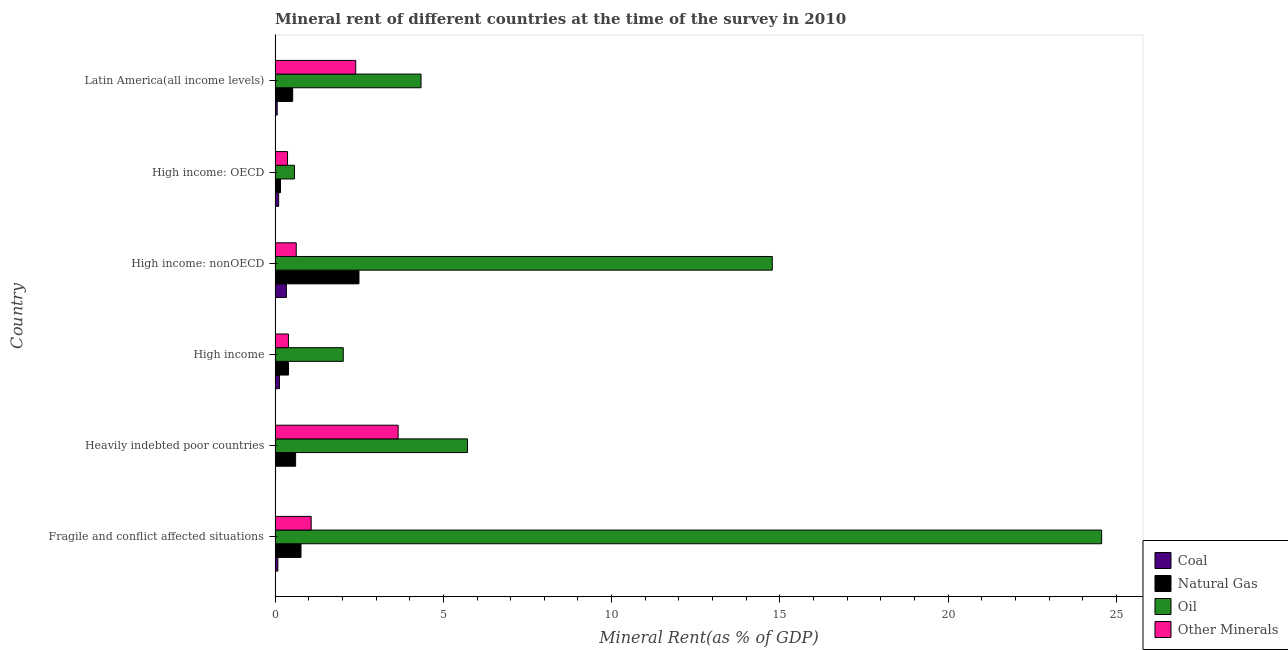How many different coloured bars are there?
Your response must be concise. 4. Are the number of bars on each tick of the Y-axis equal?
Provide a succinct answer. Yes. What is the label of the 4th group of bars from the top?
Offer a terse response. High income. What is the natural gas rent in High income: OECD?
Your answer should be very brief. 0.16. Across all countries, what is the maximum natural gas rent?
Your answer should be compact. 2.49. Across all countries, what is the minimum oil rent?
Give a very brief answer. 0.58. In which country was the  rent of other minerals maximum?
Your response must be concise. Heavily indebted poor countries. In which country was the  rent of other minerals minimum?
Offer a very short reply. High income: OECD. What is the total natural gas rent in the graph?
Give a very brief answer. 4.96. What is the difference between the  rent of other minerals in High income: OECD and that in Latin America(all income levels)?
Offer a terse response. -2.03. What is the difference between the oil rent in High income and the  rent of other minerals in Latin America(all income levels)?
Your answer should be very brief. -0.37. What is the average  rent of other minerals per country?
Offer a terse response. 1.42. What is the difference between the  rent of other minerals and coal rent in Latin America(all income levels)?
Your answer should be compact. 2.33. In how many countries, is the oil rent greater than 4 %?
Your answer should be very brief. 4. What is the ratio of the oil rent in High income to that in Latin America(all income levels)?
Your response must be concise. 0.47. Is the natural gas rent in High income: OECD less than that in High income: nonOECD?
Offer a terse response. Yes. What is the difference between the highest and the second highest coal rent?
Give a very brief answer. 0.21. What is the difference between the highest and the lowest oil rent?
Your answer should be compact. 23.98. Is the sum of the coal rent in Heavily indebted poor countries and High income greater than the maximum natural gas rent across all countries?
Offer a terse response. No. Is it the case that in every country, the sum of the coal rent and  rent of other minerals is greater than the sum of natural gas rent and oil rent?
Offer a terse response. No. What does the 1st bar from the top in High income: OECD represents?
Your answer should be compact. Other Minerals. What does the 4th bar from the bottom in Fragile and conflict affected situations represents?
Ensure brevity in your answer.  Other Minerals. Is it the case that in every country, the sum of the coal rent and natural gas rent is greater than the oil rent?
Offer a terse response. No. How many bars are there?
Your answer should be compact. 24. Are all the bars in the graph horizontal?
Make the answer very short. Yes. How many countries are there in the graph?
Your answer should be very brief. 6. What is the difference between two consecutive major ticks on the X-axis?
Your response must be concise. 5. Does the graph contain any zero values?
Make the answer very short. No. Does the graph contain grids?
Your answer should be very brief. No. Where does the legend appear in the graph?
Your response must be concise. Bottom right. How many legend labels are there?
Offer a terse response. 4. What is the title of the graph?
Your answer should be compact. Mineral rent of different countries at the time of the survey in 2010. What is the label or title of the X-axis?
Your answer should be very brief. Mineral Rent(as % of GDP). What is the Mineral Rent(as % of GDP) of Coal in Fragile and conflict affected situations?
Ensure brevity in your answer.  0.08. What is the Mineral Rent(as % of GDP) of Natural Gas in Fragile and conflict affected situations?
Provide a short and direct response. 0.77. What is the Mineral Rent(as % of GDP) in Oil in Fragile and conflict affected situations?
Offer a terse response. 24.56. What is the Mineral Rent(as % of GDP) in Other Minerals in Fragile and conflict affected situations?
Make the answer very short. 1.07. What is the Mineral Rent(as % of GDP) in Coal in Heavily indebted poor countries?
Your answer should be very brief. 0.01. What is the Mineral Rent(as % of GDP) of Natural Gas in Heavily indebted poor countries?
Offer a terse response. 0.61. What is the Mineral Rent(as % of GDP) in Oil in Heavily indebted poor countries?
Your answer should be compact. 5.72. What is the Mineral Rent(as % of GDP) of Other Minerals in Heavily indebted poor countries?
Provide a succinct answer. 3.66. What is the Mineral Rent(as % of GDP) of Coal in High income?
Provide a succinct answer. 0.13. What is the Mineral Rent(as % of GDP) in Natural Gas in High income?
Offer a very short reply. 0.4. What is the Mineral Rent(as % of GDP) in Oil in High income?
Your answer should be very brief. 2.03. What is the Mineral Rent(as % of GDP) in Other Minerals in High income?
Provide a short and direct response. 0.4. What is the Mineral Rent(as % of GDP) in Coal in High income: nonOECD?
Ensure brevity in your answer.  0.34. What is the Mineral Rent(as % of GDP) in Natural Gas in High income: nonOECD?
Provide a succinct answer. 2.49. What is the Mineral Rent(as % of GDP) of Oil in High income: nonOECD?
Your response must be concise. 14.77. What is the Mineral Rent(as % of GDP) in Other Minerals in High income: nonOECD?
Your answer should be very brief. 0.63. What is the Mineral Rent(as % of GDP) of Coal in High income: OECD?
Give a very brief answer. 0.11. What is the Mineral Rent(as % of GDP) in Natural Gas in High income: OECD?
Offer a very short reply. 0.16. What is the Mineral Rent(as % of GDP) in Oil in High income: OECD?
Your answer should be very brief. 0.58. What is the Mineral Rent(as % of GDP) in Other Minerals in High income: OECD?
Your response must be concise. 0.37. What is the Mineral Rent(as % of GDP) in Coal in Latin America(all income levels)?
Offer a terse response. 0.06. What is the Mineral Rent(as % of GDP) of Natural Gas in Latin America(all income levels)?
Your answer should be very brief. 0.52. What is the Mineral Rent(as % of GDP) in Oil in Latin America(all income levels)?
Give a very brief answer. 4.34. What is the Mineral Rent(as % of GDP) in Other Minerals in Latin America(all income levels)?
Offer a very short reply. 2.4. Across all countries, what is the maximum Mineral Rent(as % of GDP) in Coal?
Offer a terse response. 0.34. Across all countries, what is the maximum Mineral Rent(as % of GDP) of Natural Gas?
Offer a very short reply. 2.49. Across all countries, what is the maximum Mineral Rent(as % of GDP) of Oil?
Give a very brief answer. 24.56. Across all countries, what is the maximum Mineral Rent(as % of GDP) of Other Minerals?
Your response must be concise. 3.66. Across all countries, what is the minimum Mineral Rent(as % of GDP) of Coal?
Offer a terse response. 0.01. Across all countries, what is the minimum Mineral Rent(as % of GDP) of Natural Gas?
Your answer should be very brief. 0.16. Across all countries, what is the minimum Mineral Rent(as % of GDP) in Oil?
Offer a very short reply. 0.58. Across all countries, what is the minimum Mineral Rent(as % of GDP) of Other Minerals?
Provide a succinct answer. 0.37. What is the total Mineral Rent(as % of GDP) of Coal in the graph?
Make the answer very short. 0.73. What is the total Mineral Rent(as % of GDP) in Natural Gas in the graph?
Offer a very short reply. 4.96. What is the total Mineral Rent(as % of GDP) in Oil in the graph?
Give a very brief answer. 51.99. What is the total Mineral Rent(as % of GDP) of Other Minerals in the graph?
Your answer should be very brief. 8.52. What is the difference between the Mineral Rent(as % of GDP) in Coal in Fragile and conflict affected situations and that in Heavily indebted poor countries?
Keep it short and to the point. 0.07. What is the difference between the Mineral Rent(as % of GDP) of Natural Gas in Fragile and conflict affected situations and that in Heavily indebted poor countries?
Offer a very short reply. 0.16. What is the difference between the Mineral Rent(as % of GDP) in Oil in Fragile and conflict affected situations and that in Heavily indebted poor countries?
Make the answer very short. 18.84. What is the difference between the Mineral Rent(as % of GDP) of Other Minerals in Fragile and conflict affected situations and that in Heavily indebted poor countries?
Keep it short and to the point. -2.58. What is the difference between the Mineral Rent(as % of GDP) in Coal in Fragile and conflict affected situations and that in High income?
Give a very brief answer. -0.05. What is the difference between the Mineral Rent(as % of GDP) of Natural Gas in Fragile and conflict affected situations and that in High income?
Provide a succinct answer. 0.37. What is the difference between the Mineral Rent(as % of GDP) of Oil in Fragile and conflict affected situations and that in High income?
Provide a short and direct response. 22.53. What is the difference between the Mineral Rent(as % of GDP) of Other Minerals in Fragile and conflict affected situations and that in High income?
Provide a succinct answer. 0.68. What is the difference between the Mineral Rent(as % of GDP) of Coal in Fragile and conflict affected situations and that in High income: nonOECD?
Give a very brief answer. -0.25. What is the difference between the Mineral Rent(as % of GDP) in Natural Gas in Fragile and conflict affected situations and that in High income: nonOECD?
Ensure brevity in your answer.  -1.72. What is the difference between the Mineral Rent(as % of GDP) of Oil in Fragile and conflict affected situations and that in High income: nonOECD?
Your response must be concise. 9.79. What is the difference between the Mineral Rent(as % of GDP) in Other Minerals in Fragile and conflict affected situations and that in High income: nonOECD?
Your answer should be compact. 0.44. What is the difference between the Mineral Rent(as % of GDP) of Coal in Fragile and conflict affected situations and that in High income: OECD?
Your answer should be very brief. -0.02. What is the difference between the Mineral Rent(as % of GDP) in Natural Gas in Fragile and conflict affected situations and that in High income: OECD?
Offer a very short reply. 0.61. What is the difference between the Mineral Rent(as % of GDP) in Oil in Fragile and conflict affected situations and that in High income: OECD?
Ensure brevity in your answer.  23.98. What is the difference between the Mineral Rent(as % of GDP) of Other Minerals in Fragile and conflict affected situations and that in High income: OECD?
Make the answer very short. 0.7. What is the difference between the Mineral Rent(as % of GDP) in Coal in Fragile and conflict affected situations and that in Latin America(all income levels)?
Offer a terse response. 0.02. What is the difference between the Mineral Rent(as % of GDP) in Natural Gas in Fragile and conflict affected situations and that in Latin America(all income levels)?
Your answer should be very brief. 0.25. What is the difference between the Mineral Rent(as % of GDP) of Oil in Fragile and conflict affected situations and that in Latin America(all income levels)?
Ensure brevity in your answer.  20.22. What is the difference between the Mineral Rent(as % of GDP) in Other Minerals in Fragile and conflict affected situations and that in Latin America(all income levels)?
Your response must be concise. -1.32. What is the difference between the Mineral Rent(as % of GDP) in Coal in Heavily indebted poor countries and that in High income?
Provide a succinct answer. -0.12. What is the difference between the Mineral Rent(as % of GDP) in Natural Gas in Heavily indebted poor countries and that in High income?
Your response must be concise. 0.21. What is the difference between the Mineral Rent(as % of GDP) in Oil in Heavily indebted poor countries and that in High income?
Offer a very short reply. 3.69. What is the difference between the Mineral Rent(as % of GDP) of Other Minerals in Heavily indebted poor countries and that in High income?
Offer a terse response. 3.26. What is the difference between the Mineral Rent(as % of GDP) of Coal in Heavily indebted poor countries and that in High income: nonOECD?
Offer a terse response. -0.32. What is the difference between the Mineral Rent(as % of GDP) in Natural Gas in Heavily indebted poor countries and that in High income: nonOECD?
Provide a short and direct response. -1.88. What is the difference between the Mineral Rent(as % of GDP) of Oil in Heavily indebted poor countries and that in High income: nonOECD?
Your answer should be compact. -9.06. What is the difference between the Mineral Rent(as % of GDP) of Other Minerals in Heavily indebted poor countries and that in High income: nonOECD?
Offer a terse response. 3.03. What is the difference between the Mineral Rent(as % of GDP) of Coal in Heavily indebted poor countries and that in High income: OECD?
Offer a terse response. -0.09. What is the difference between the Mineral Rent(as % of GDP) of Natural Gas in Heavily indebted poor countries and that in High income: OECD?
Make the answer very short. 0.45. What is the difference between the Mineral Rent(as % of GDP) of Oil in Heavily indebted poor countries and that in High income: OECD?
Your answer should be compact. 5.14. What is the difference between the Mineral Rent(as % of GDP) in Other Minerals in Heavily indebted poor countries and that in High income: OECD?
Offer a terse response. 3.29. What is the difference between the Mineral Rent(as % of GDP) in Coal in Heavily indebted poor countries and that in Latin America(all income levels)?
Keep it short and to the point. -0.05. What is the difference between the Mineral Rent(as % of GDP) in Natural Gas in Heavily indebted poor countries and that in Latin America(all income levels)?
Keep it short and to the point. 0.09. What is the difference between the Mineral Rent(as % of GDP) in Oil in Heavily indebted poor countries and that in Latin America(all income levels)?
Provide a succinct answer. 1.38. What is the difference between the Mineral Rent(as % of GDP) of Other Minerals in Heavily indebted poor countries and that in Latin America(all income levels)?
Offer a very short reply. 1.26. What is the difference between the Mineral Rent(as % of GDP) of Coal in High income and that in High income: nonOECD?
Provide a succinct answer. -0.21. What is the difference between the Mineral Rent(as % of GDP) of Natural Gas in High income and that in High income: nonOECD?
Offer a very short reply. -2.09. What is the difference between the Mineral Rent(as % of GDP) of Oil in High income and that in High income: nonOECD?
Ensure brevity in your answer.  -12.75. What is the difference between the Mineral Rent(as % of GDP) in Other Minerals in High income and that in High income: nonOECD?
Keep it short and to the point. -0.23. What is the difference between the Mineral Rent(as % of GDP) in Coal in High income and that in High income: OECD?
Provide a short and direct response. 0.02. What is the difference between the Mineral Rent(as % of GDP) in Natural Gas in High income and that in High income: OECD?
Offer a very short reply. 0.24. What is the difference between the Mineral Rent(as % of GDP) in Oil in High income and that in High income: OECD?
Provide a short and direct response. 1.45. What is the difference between the Mineral Rent(as % of GDP) of Other Minerals in High income and that in High income: OECD?
Ensure brevity in your answer.  0.03. What is the difference between the Mineral Rent(as % of GDP) of Coal in High income and that in Latin America(all income levels)?
Make the answer very short. 0.07. What is the difference between the Mineral Rent(as % of GDP) in Natural Gas in High income and that in Latin America(all income levels)?
Your answer should be compact. -0.12. What is the difference between the Mineral Rent(as % of GDP) in Oil in High income and that in Latin America(all income levels)?
Offer a terse response. -2.31. What is the difference between the Mineral Rent(as % of GDP) in Other Minerals in High income and that in Latin America(all income levels)?
Provide a succinct answer. -2. What is the difference between the Mineral Rent(as % of GDP) in Coal in High income: nonOECD and that in High income: OECD?
Your answer should be compact. 0.23. What is the difference between the Mineral Rent(as % of GDP) of Natural Gas in High income: nonOECD and that in High income: OECD?
Your answer should be compact. 2.33. What is the difference between the Mineral Rent(as % of GDP) in Oil in High income: nonOECD and that in High income: OECD?
Offer a very short reply. 14.2. What is the difference between the Mineral Rent(as % of GDP) in Other Minerals in High income: nonOECD and that in High income: OECD?
Offer a terse response. 0.26. What is the difference between the Mineral Rent(as % of GDP) of Coal in High income: nonOECD and that in Latin America(all income levels)?
Offer a very short reply. 0.27. What is the difference between the Mineral Rent(as % of GDP) in Natural Gas in High income: nonOECD and that in Latin America(all income levels)?
Offer a very short reply. 1.97. What is the difference between the Mineral Rent(as % of GDP) in Oil in High income: nonOECD and that in Latin America(all income levels)?
Provide a succinct answer. 10.44. What is the difference between the Mineral Rent(as % of GDP) of Other Minerals in High income: nonOECD and that in Latin America(all income levels)?
Make the answer very short. -1.77. What is the difference between the Mineral Rent(as % of GDP) of Coal in High income: OECD and that in Latin America(all income levels)?
Provide a short and direct response. 0.04. What is the difference between the Mineral Rent(as % of GDP) in Natural Gas in High income: OECD and that in Latin America(all income levels)?
Provide a succinct answer. -0.36. What is the difference between the Mineral Rent(as % of GDP) in Oil in High income: OECD and that in Latin America(all income levels)?
Keep it short and to the point. -3.76. What is the difference between the Mineral Rent(as % of GDP) of Other Minerals in High income: OECD and that in Latin America(all income levels)?
Your answer should be very brief. -2.03. What is the difference between the Mineral Rent(as % of GDP) in Coal in Fragile and conflict affected situations and the Mineral Rent(as % of GDP) in Natural Gas in Heavily indebted poor countries?
Your answer should be very brief. -0.53. What is the difference between the Mineral Rent(as % of GDP) of Coal in Fragile and conflict affected situations and the Mineral Rent(as % of GDP) of Oil in Heavily indebted poor countries?
Ensure brevity in your answer.  -5.63. What is the difference between the Mineral Rent(as % of GDP) in Coal in Fragile and conflict affected situations and the Mineral Rent(as % of GDP) in Other Minerals in Heavily indebted poor countries?
Your answer should be very brief. -3.57. What is the difference between the Mineral Rent(as % of GDP) of Natural Gas in Fragile and conflict affected situations and the Mineral Rent(as % of GDP) of Oil in Heavily indebted poor countries?
Provide a short and direct response. -4.95. What is the difference between the Mineral Rent(as % of GDP) in Natural Gas in Fragile and conflict affected situations and the Mineral Rent(as % of GDP) in Other Minerals in Heavily indebted poor countries?
Your answer should be compact. -2.89. What is the difference between the Mineral Rent(as % of GDP) of Oil in Fragile and conflict affected situations and the Mineral Rent(as % of GDP) of Other Minerals in Heavily indebted poor countries?
Your answer should be compact. 20.9. What is the difference between the Mineral Rent(as % of GDP) in Coal in Fragile and conflict affected situations and the Mineral Rent(as % of GDP) in Natural Gas in High income?
Your response must be concise. -0.32. What is the difference between the Mineral Rent(as % of GDP) in Coal in Fragile and conflict affected situations and the Mineral Rent(as % of GDP) in Oil in High income?
Your answer should be compact. -1.94. What is the difference between the Mineral Rent(as % of GDP) in Coal in Fragile and conflict affected situations and the Mineral Rent(as % of GDP) in Other Minerals in High income?
Offer a terse response. -0.31. What is the difference between the Mineral Rent(as % of GDP) of Natural Gas in Fragile and conflict affected situations and the Mineral Rent(as % of GDP) of Oil in High income?
Provide a short and direct response. -1.26. What is the difference between the Mineral Rent(as % of GDP) of Natural Gas in Fragile and conflict affected situations and the Mineral Rent(as % of GDP) of Other Minerals in High income?
Give a very brief answer. 0.37. What is the difference between the Mineral Rent(as % of GDP) in Oil in Fragile and conflict affected situations and the Mineral Rent(as % of GDP) in Other Minerals in High income?
Your answer should be compact. 24.16. What is the difference between the Mineral Rent(as % of GDP) in Coal in Fragile and conflict affected situations and the Mineral Rent(as % of GDP) in Natural Gas in High income: nonOECD?
Provide a short and direct response. -2.41. What is the difference between the Mineral Rent(as % of GDP) of Coal in Fragile and conflict affected situations and the Mineral Rent(as % of GDP) of Oil in High income: nonOECD?
Your answer should be compact. -14.69. What is the difference between the Mineral Rent(as % of GDP) in Coal in Fragile and conflict affected situations and the Mineral Rent(as % of GDP) in Other Minerals in High income: nonOECD?
Offer a very short reply. -0.55. What is the difference between the Mineral Rent(as % of GDP) in Natural Gas in Fragile and conflict affected situations and the Mineral Rent(as % of GDP) in Oil in High income: nonOECD?
Offer a terse response. -14. What is the difference between the Mineral Rent(as % of GDP) in Natural Gas in Fragile and conflict affected situations and the Mineral Rent(as % of GDP) in Other Minerals in High income: nonOECD?
Your answer should be compact. 0.14. What is the difference between the Mineral Rent(as % of GDP) in Oil in Fragile and conflict affected situations and the Mineral Rent(as % of GDP) in Other Minerals in High income: nonOECD?
Offer a terse response. 23.93. What is the difference between the Mineral Rent(as % of GDP) of Coal in Fragile and conflict affected situations and the Mineral Rent(as % of GDP) of Natural Gas in High income: OECD?
Give a very brief answer. -0.08. What is the difference between the Mineral Rent(as % of GDP) in Coal in Fragile and conflict affected situations and the Mineral Rent(as % of GDP) in Oil in High income: OECD?
Keep it short and to the point. -0.49. What is the difference between the Mineral Rent(as % of GDP) in Coal in Fragile and conflict affected situations and the Mineral Rent(as % of GDP) in Other Minerals in High income: OECD?
Provide a succinct answer. -0.29. What is the difference between the Mineral Rent(as % of GDP) in Natural Gas in Fragile and conflict affected situations and the Mineral Rent(as % of GDP) in Oil in High income: OECD?
Your answer should be compact. 0.19. What is the difference between the Mineral Rent(as % of GDP) of Natural Gas in Fragile and conflict affected situations and the Mineral Rent(as % of GDP) of Other Minerals in High income: OECD?
Offer a very short reply. 0.4. What is the difference between the Mineral Rent(as % of GDP) of Oil in Fragile and conflict affected situations and the Mineral Rent(as % of GDP) of Other Minerals in High income: OECD?
Make the answer very short. 24.19. What is the difference between the Mineral Rent(as % of GDP) of Coal in Fragile and conflict affected situations and the Mineral Rent(as % of GDP) of Natural Gas in Latin America(all income levels)?
Provide a succinct answer. -0.44. What is the difference between the Mineral Rent(as % of GDP) in Coal in Fragile and conflict affected situations and the Mineral Rent(as % of GDP) in Oil in Latin America(all income levels)?
Keep it short and to the point. -4.25. What is the difference between the Mineral Rent(as % of GDP) in Coal in Fragile and conflict affected situations and the Mineral Rent(as % of GDP) in Other Minerals in Latin America(all income levels)?
Your answer should be very brief. -2.31. What is the difference between the Mineral Rent(as % of GDP) of Natural Gas in Fragile and conflict affected situations and the Mineral Rent(as % of GDP) of Oil in Latin America(all income levels)?
Your response must be concise. -3.57. What is the difference between the Mineral Rent(as % of GDP) of Natural Gas in Fragile and conflict affected situations and the Mineral Rent(as % of GDP) of Other Minerals in Latin America(all income levels)?
Provide a succinct answer. -1.63. What is the difference between the Mineral Rent(as % of GDP) in Oil in Fragile and conflict affected situations and the Mineral Rent(as % of GDP) in Other Minerals in Latin America(all income levels)?
Provide a succinct answer. 22.16. What is the difference between the Mineral Rent(as % of GDP) in Coal in Heavily indebted poor countries and the Mineral Rent(as % of GDP) in Natural Gas in High income?
Make the answer very short. -0.39. What is the difference between the Mineral Rent(as % of GDP) in Coal in Heavily indebted poor countries and the Mineral Rent(as % of GDP) in Oil in High income?
Provide a succinct answer. -2.01. What is the difference between the Mineral Rent(as % of GDP) in Coal in Heavily indebted poor countries and the Mineral Rent(as % of GDP) in Other Minerals in High income?
Your answer should be compact. -0.38. What is the difference between the Mineral Rent(as % of GDP) in Natural Gas in Heavily indebted poor countries and the Mineral Rent(as % of GDP) in Oil in High income?
Give a very brief answer. -1.42. What is the difference between the Mineral Rent(as % of GDP) in Natural Gas in Heavily indebted poor countries and the Mineral Rent(as % of GDP) in Other Minerals in High income?
Offer a terse response. 0.21. What is the difference between the Mineral Rent(as % of GDP) in Oil in Heavily indebted poor countries and the Mineral Rent(as % of GDP) in Other Minerals in High income?
Keep it short and to the point. 5.32. What is the difference between the Mineral Rent(as % of GDP) of Coal in Heavily indebted poor countries and the Mineral Rent(as % of GDP) of Natural Gas in High income: nonOECD?
Give a very brief answer. -2.48. What is the difference between the Mineral Rent(as % of GDP) of Coal in Heavily indebted poor countries and the Mineral Rent(as % of GDP) of Oil in High income: nonOECD?
Your response must be concise. -14.76. What is the difference between the Mineral Rent(as % of GDP) in Coal in Heavily indebted poor countries and the Mineral Rent(as % of GDP) in Other Minerals in High income: nonOECD?
Provide a succinct answer. -0.61. What is the difference between the Mineral Rent(as % of GDP) of Natural Gas in Heavily indebted poor countries and the Mineral Rent(as % of GDP) of Oil in High income: nonOECD?
Provide a succinct answer. -14.16. What is the difference between the Mineral Rent(as % of GDP) of Natural Gas in Heavily indebted poor countries and the Mineral Rent(as % of GDP) of Other Minerals in High income: nonOECD?
Ensure brevity in your answer.  -0.02. What is the difference between the Mineral Rent(as % of GDP) in Oil in Heavily indebted poor countries and the Mineral Rent(as % of GDP) in Other Minerals in High income: nonOECD?
Provide a short and direct response. 5.09. What is the difference between the Mineral Rent(as % of GDP) in Coal in Heavily indebted poor countries and the Mineral Rent(as % of GDP) in Natural Gas in High income: OECD?
Make the answer very short. -0.15. What is the difference between the Mineral Rent(as % of GDP) of Coal in Heavily indebted poor countries and the Mineral Rent(as % of GDP) of Oil in High income: OECD?
Offer a terse response. -0.56. What is the difference between the Mineral Rent(as % of GDP) of Coal in Heavily indebted poor countries and the Mineral Rent(as % of GDP) of Other Minerals in High income: OECD?
Provide a short and direct response. -0.36. What is the difference between the Mineral Rent(as % of GDP) of Natural Gas in Heavily indebted poor countries and the Mineral Rent(as % of GDP) of Oil in High income: OECD?
Your answer should be very brief. 0.03. What is the difference between the Mineral Rent(as % of GDP) in Natural Gas in Heavily indebted poor countries and the Mineral Rent(as % of GDP) in Other Minerals in High income: OECD?
Ensure brevity in your answer.  0.24. What is the difference between the Mineral Rent(as % of GDP) of Oil in Heavily indebted poor countries and the Mineral Rent(as % of GDP) of Other Minerals in High income: OECD?
Keep it short and to the point. 5.35. What is the difference between the Mineral Rent(as % of GDP) of Coal in Heavily indebted poor countries and the Mineral Rent(as % of GDP) of Natural Gas in Latin America(all income levels)?
Your response must be concise. -0.51. What is the difference between the Mineral Rent(as % of GDP) in Coal in Heavily indebted poor countries and the Mineral Rent(as % of GDP) in Oil in Latin America(all income levels)?
Offer a terse response. -4.32. What is the difference between the Mineral Rent(as % of GDP) of Coal in Heavily indebted poor countries and the Mineral Rent(as % of GDP) of Other Minerals in Latin America(all income levels)?
Make the answer very short. -2.38. What is the difference between the Mineral Rent(as % of GDP) in Natural Gas in Heavily indebted poor countries and the Mineral Rent(as % of GDP) in Oil in Latin America(all income levels)?
Give a very brief answer. -3.73. What is the difference between the Mineral Rent(as % of GDP) in Natural Gas in Heavily indebted poor countries and the Mineral Rent(as % of GDP) in Other Minerals in Latin America(all income levels)?
Your response must be concise. -1.79. What is the difference between the Mineral Rent(as % of GDP) of Oil in Heavily indebted poor countries and the Mineral Rent(as % of GDP) of Other Minerals in Latin America(all income levels)?
Give a very brief answer. 3.32. What is the difference between the Mineral Rent(as % of GDP) in Coal in High income and the Mineral Rent(as % of GDP) in Natural Gas in High income: nonOECD?
Your response must be concise. -2.36. What is the difference between the Mineral Rent(as % of GDP) of Coal in High income and the Mineral Rent(as % of GDP) of Oil in High income: nonOECD?
Ensure brevity in your answer.  -14.64. What is the difference between the Mineral Rent(as % of GDP) of Coal in High income and the Mineral Rent(as % of GDP) of Other Minerals in High income: nonOECD?
Keep it short and to the point. -0.5. What is the difference between the Mineral Rent(as % of GDP) of Natural Gas in High income and the Mineral Rent(as % of GDP) of Oil in High income: nonOECD?
Your response must be concise. -14.37. What is the difference between the Mineral Rent(as % of GDP) in Natural Gas in High income and the Mineral Rent(as % of GDP) in Other Minerals in High income: nonOECD?
Offer a very short reply. -0.23. What is the difference between the Mineral Rent(as % of GDP) in Oil in High income and the Mineral Rent(as % of GDP) in Other Minerals in High income: nonOECD?
Give a very brief answer. 1.4. What is the difference between the Mineral Rent(as % of GDP) of Coal in High income and the Mineral Rent(as % of GDP) of Natural Gas in High income: OECD?
Provide a succinct answer. -0.03. What is the difference between the Mineral Rent(as % of GDP) of Coal in High income and the Mineral Rent(as % of GDP) of Oil in High income: OECD?
Make the answer very short. -0.45. What is the difference between the Mineral Rent(as % of GDP) of Coal in High income and the Mineral Rent(as % of GDP) of Other Minerals in High income: OECD?
Your answer should be very brief. -0.24. What is the difference between the Mineral Rent(as % of GDP) of Natural Gas in High income and the Mineral Rent(as % of GDP) of Oil in High income: OECD?
Give a very brief answer. -0.18. What is the difference between the Mineral Rent(as % of GDP) of Natural Gas in High income and the Mineral Rent(as % of GDP) of Other Minerals in High income: OECD?
Offer a very short reply. 0.03. What is the difference between the Mineral Rent(as % of GDP) in Oil in High income and the Mineral Rent(as % of GDP) in Other Minerals in High income: OECD?
Ensure brevity in your answer.  1.66. What is the difference between the Mineral Rent(as % of GDP) of Coal in High income and the Mineral Rent(as % of GDP) of Natural Gas in Latin America(all income levels)?
Provide a succinct answer. -0.39. What is the difference between the Mineral Rent(as % of GDP) in Coal in High income and the Mineral Rent(as % of GDP) in Oil in Latin America(all income levels)?
Your response must be concise. -4.21. What is the difference between the Mineral Rent(as % of GDP) in Coal in High income and the Mineral Rent(as % of GDP) in Other Minerals in Latin America(all income levels)?
Make the answer very short. -2.27. What is the difference between the Mineral Rent(as % of GDP) of Natural Gas in High income and the Mineral Rent(as % of GDP) of Oil in Latin America(all income levels)?
Provide a short and direct response. -3.94. What is the difference between the Mineral Rent(as % of GDP) of Natural Gas in High income and the Mineral Rent(as % of GDP) of Other Minerals in Latin America(all income levels)?
Make the answer very short. -2. What is the difference between the Mineral Rent(as % of GDP) in Oil in High income and the Mineral Rent(as % of GDP) in Other Minerals in Latin America(all income levels)?
Your answer should be compact. -0.37. What is the difference between the Mineral Rent(as % of GDP) in Coal in High income: nonOECD and the Mineral Rent(as % of GDP) in Natural Gas in High income: OECD?
Give a very brief answer. 0.18. What is the difference between the Mineral Rent(as % of GDP) in Coal in High income: nonOECD and the Mineral Rent(as % of GDP) in Oil in High income: OECD?
Your response must be concise. -0.24. What is the difference between the Mineral Rent(as % of GDP) of Coal in High income: nonOECD and the Mineral Rent(as % of GDP) of Other Minerals in High income: OECD?
Ensure brevity in your answer.  -0.03. What is the difference between the Mineral Rent(as % of GDP) in Natural Gas in High income: nonOECD and the Mineral Rent(as % of GDP) in Oil in High income: OECD?
Your response must be concise. 1.92. What is the difference between the Mineral Rent(as % of GDP) in Natural Gas in High income: nonOECD and the Mineral Rent(as % of GDP) in Other Minerals in High income: OECD?
Offer a very short reply. 2.12. What is the difference between the Mineral Rent(as % of GDP) of Oil in High income: nonOECD and the Mineral Rent(as % of GDP) of Other Minerals in High income: OECD?
Your answer should be compact. 14.4. What is the difference between the Mineral Rent(as % of GDP) of Coal in High income: nonOECD and the Mineral Rent(as % of GDP) of Natural Gas in Latin America(all income levels)?
Provide a succinct answer. -0.19. What is the difference between the Mineral Rent(as % of GDP) of Coal in High income: nonOECD and the Mineral Rent(as % of GDP) of Oil in Latin America(all income levels)?
Provide a succinct answer. -4. What is the difference between the Mineral Rent(as % of GDP) in Coal in High income: nonOECD and the Mineral Rent(as % of GDP) in Other Minerals in Latin America(all income levels)?
Ensure brevity in your answer.  -2.06. What is the difference between the Mineral Rent(as % of GDP) in Natural Gas in High income: nonOECD and the Mineral Rent(as % of GDP) in Oil in Latin America(all income levels)?
Your response must be concise. -1.84. What is the difference between the Mineral Rent(as % of GDP) in Natural Gas in High income: nonOECD and the Mineral Rent(as % of GDP) in Other Minerals in Latin America(all income levels)?
Ensure brevity in your answer.  0.1. What is the difference between the Mineral Rent(as % of GDP) of Oil in High income: nonOECD and the Mineral Rent(as % of GDP) of Other Minerals in Latin America(all income levels)?
Provide a short and direct response. 12.38. What is the difference between the Mineral Rent(as % of GDP) in Coal in High income: OECD and the Mineral Rent(as % of GDP) in Natural Gas in Latin America(all income levels)?
Offer a very short reply. -0.42. What is the difference between the Mineral Rent(as % of GDP) in Coal in High income: OECD and the Mineral Rent(as % of GDP) in Oil in Latin America(all income levels)?
Provide a short and direct response. -4.23. What is the difference between the Mineral Rent(as % of GDP) of Coal in High income: OECD and the Mineral Rent(as % of GDP) of Other Minerals in Latin America(all income levels)?
Your response must be concise. -2.29. What is the difference between the Mineral Rent(as % of GDP) in Natural Gas in High income: OECD and the Mineral Rent(as % of GDP) in Oil in Latin America(all income levels)?
Your answer should be very brief. -4.18. What is the difference between the Mineral Rent(as % of GDP) of Natural Gas in High income: OECD and the Mineral Rent(as % of GDP) of Other Minerals in Latin America(all income levels)?
Provide a short and direct response. -2.24. What is the difference between the Mineral Rent(as % of GDP) of Oil in High income: OECD and the Mineral Rent(as % of GDP) of Other Minerals in Latin America(all income levels)?
Keep it short and to the point. -1.82. What is the average Mineral Rent(as % of GDP) of Coal per country?
Your response must be concise. 0.12. What is the average Mineral Rent(as % of GDP) in Natural Gas per country?
Ensure brevity in your answer.  0.83. What is the average Mineral Rent(as % of GDP) of Oil per country?
Keep it short and to the point. 8.66. What is the average Mineral Rent(as % of GDP) in Other Minerals per country?
Offer a very short reply. 1.42. What is the difference between the Mineral Rent(as % of GDP) of Coal and Mineral Rent(as % of GDP) of Natural Gas in Fragile and conflict affected situations?
Offer a very short reply. -0.69. What is the difference between the Mineral Rent(as % of GDP) of Coal and Mineral Rent(as % of GDP) of Oil in Fragile and conflict affected situations?
Provide a short and direct response. -24.48. What is the difference between the Mineral Rent(as % of GDP) of Coal and Mineral Rent(as % of GDP) of Other Minerals in Fragile and conflict affected situations?
Give a very brief answer. -0.99. What is the difference between the Mineral Rent(as % of GDP) in Natural Gas and Mineral Rent(as % of GDP) in Oil in Fragile and conflict affected situations?
Ensure brevity in your answer.  -23.79. What is the difference between the Mineral Rent(as % of GDP) of Natural Gas and Mineral Rent(as % of GDP) of Other Minerals in Fragile and conflict affected situations?
Your answer should be very brief. -0.3. What is the difference between the Mineral Rent(as % of GDP) in Oil and Mineral Rent(as % of GDP) in Other Minerals in Fragile and conflict affected situations?
Make the answer very short. 23.49. What is the difference between the Mineral Rent(as % of GDP) in Coal and Mineral Rent(as % of GDP) in Natural Gas in Heavily indebted poor countries?
Your response must be concise. -0.6. What is the difference between the Mineral Rent(as % of GDP) in Coal and Mineral Rent(as % of GDP) in Oil in Heavily indebted poor countries?
Your answer should be compact. -5.7. What is the difference between the Mineral Rent(as % of GDP) in Coal and Mineral Rent(as % of GDP) in Other Minerals in Heavily indebted poor countries?
Offer a terse response. -3.64. What is the difference between the Mineral Rent(as % of GDP) in Natural Gas and Mineral Rent(as % of GDP) in Oil in Heavily indebted poor countries?
Ensure brevity in your answer.  -5.11. What is the difference between the Mineral Rent(as % of GDP) of Natural Gas and Mineral Rent(as % of GDP) of Other Minerals in Heavily indebted poor countries?
Offer a terse response. -3.05. What is the difference between the Mineral Rent(as % of GDP) in Oil and Mineral Rent(as % of GDP) in Other Minerals in Heavily indebted poor countries?
Your response must be concise. 2.06. What is the difference between the Mineral Rent(as % of GDP) of Coal and Mineral Rent(as % of GDP) of Natural Gas in High income?
Ensure brevity in your answer.  -0.27. What is the difference between the Mineral Rent(as % of GDP) in Coal and Mineral Rent(as % of GDP) in Oil in High income?
Your answer should be very brief. -1.9. What is the difference between the Mineral Rent(as % of GDP) of Coal and Mineral Rent(as % of GDP) of Other Minerals in High income?
Provide a succinct answer. -0.27. What is the difference between the Mineral Rent(as % of GDP) of Natural Gas and Mineral Rent(as % of GDP) of Oil in High income?
Provide a succinct answer. -1.63. What is the difference between the Mineral Rent(as % of GDP) in Natural Gas and Mineral Rent(as % of GDP) in Other Minerals in High income?
Offer a terse response. 0. What is the difference between the Mineral Rent(as % of GDP) in Oil and Mineral Rent(as % of GDP) in Other Minerals in High income?
Make the answer very short. 1.63. What is the difference between the Mineral Rent(as % of GDP) of Coal and Mineral Rent(as % of GDP) of Natural Gas in High income: nonOECD?
Provide a short and direct response. -2.16. What is the difference between the Mineral Rent(as % of GDP) in Coal and Mineral Rent(as % of GDP) in Oil in High income: nonOECD?
Provide a short and direct response. -14.44. What is the difference between the Mineral Rent(as % of GDP) of Coal and Mineral Rent(as % of GDP) of Other Minerals in High income: nonOECD?
Your answer should be very brief. -0.29. What is the difference between the Mineral Rent(as % of GDP) in Natural Gas and Mineral Rent(as % of GDP) in Oil in High income: nonOECD?
Offer a very short reply. -12.28. What is the difference between the Mineral Rent(as % of GDP) in Natural Gas and Mineral Rent(as % of GDP) in Other Minerals in High income: nonOECD?
Make the answer very short. 1.86. What is the difference between the Mineral Rent(as % of GDP) in Oil and Mineral Rent(as % of GDP) in Other Minerals in High income: nonOECD?
Your answer should be very brief. 14.14. What is the difference between the Mineral Rent(as % of GDP) in Coal and Mineral Rent(as % of GDP) in Natural Gas in High income: OECD?
Give a very brief answer. -0.06. What is the difference between the Mineral Rent(as % of GDP) in Coal and Mineral Rent(as % of GDP) in Oil in High income: OECD?
Make the answer very short. -0.47. What is the difference between the Mineral Rent(as % of GDP) in Coal and Mineral Rent(as % of GDP) in Other Minerals in High income: OECD?
Your answer should be compact. -0.26. What is the difference between the Mineral Rent(as % of GDP) in Natural Gas and Mineral Rent(as % of GDP) in Oil in High income: OECD?
Your answer should be very brief. -0.41. What is the difference between the Mineral Rent(as % of GDP) in Natural Gas and Mineral Rent(as % of GDP) in Other Minerals in High income: OECD?
Make the answer very short. -0.21. What is the difference between the Mineral Rent(as % of GDP) in Oil and Mineral Rent(as % of GDP) in Other Minerals in High income: OECD?
Your response must be concise. 0.21. What is the difference between the Mineral Rent(as % of GDP) of Coal and Mineral Rent(as % of GDP) of Natural Gas in Latin America(all income levels)?
Offer a terse response. -0.46. What is the difference between the Mineral Rent(as % of GDP) of Coal and Mineral Rent(as % of GDP) of Oil in Latin America(all income levels)?
Your answer should be very brief. -4.27. What is the difference between the Mineral Rent(as % of GDP) in Coal and Mineral Rent(as % of GDP) in Other Minerals in Latin America(all income levels)?
Offer a terse response. -2.33. What is the difference between the Mineral Rent(as % of GDP) in Natural Gas and Mineral Rent(as % of GDP) in Oil in Latin America(all income levels)?
Provide a short and direct response. -3.81. What is the difference between the Mineral Rent(as % of GDP) of Natural Gas and Mineral Rent(as % of GDP) of Other Minerals in Latin America(all income levels)?
Your answer should be compact. -1.87. What is the difference between the Mineral Rent(as % of GDP) of Oil and Mineral Rent(as % of GDP) of Other Minerals in Latin America(all income levels)?
Your response must be concise. 1.94. What is the ratio of the Mineral Rent(as % of GDP) of Coal in Fragile and conflict affected situations to that in Heavily indebted poor countries?
Give a very brief answer. 5.7. What is the ratio of the Mineral Rent(as % of GDP) in Natural Gas in Fragile and conflict affected situations to that in Heavily indebted poor countries?
Your answer should be compact. 1.26. What is the ratio of the Mineral Rent(as % of GDP) of Oil in Fragile and conflict affected situations to that in Heavily indebted poor countries?
Make the answer very short. 4.3. What is the ratio of the Mineral Rent(as % of GDP) of Other Minerals in Fragile and conflict affected situations to that in Heavily indebted poor countries?
Offer a very short reply. 0.29. What is the ratio of the Mineral Rent(as % of GDP) in Coal in Fragile and conflict affected situations to that in High income?
Your response must be concise. 0.63. What is the ratio of the Mineral Rent(as % of GDP) in Natural Gas in Fragile and conflict affected situations to that in High income?
Provide a short and direct response. 1.93. What is the ratio of the Mineral Rent(as % of GDP) in Oil in Fragile and conflict affected situations to that in High income?
Your response must be concise. 12.12. What is the ratio of the Mineral Rent(as % of GDP) of Other Minerals in Fragile and conflict affected situations to that in High income?
Give a very brief answer. 2.71. What is the ratio of the Mineral Rent(as % of GDP) of Coal in Fragile and conflict affected situations to that in High income: nonOECD?
Provide a short and direct response. 0.24. What is the ratio of the Mineral Rent(as % of GDP) of Natural Gas in Fragile and conflict affected situations to that in High income: nonOECD?
Provide a short and direct response. 0.31. What is the ratio of the Mineral Rent(as % of GDP) in Oil in Fragile and conflict affected situations to that in High income: nonOECD?
Offer a terse response. 1.66. What is the ratio of the Mineral Rent(as % of GDP) in Other Minerals in Fragile and conflict affected situations to that in High income: nonOECD?
Give a very brief answer. 1.71. What is the ratio of the Mineral Rent(as % of GDP) in Coal in Fragile and conflict affected situations to that in High income: OECD?
Ensure brevity in your answer.  0.77. What is the ratio of the Mineral Rent(as % of GDP) of Natural Gas in Fragile and conflict affected situations to that in High income: OECD?
Your response must be concise. 4.77. What is the ratio of the Mineral Rent(as % of GDP) of Oil in Fragile and conflict affected situations to that in High income: OECD?
Your response must be concise. 42.66. What is the ratio of the Mineral Rent(as % of GDP) in Other Minerals in Fragile and conflict affected situations to that in High income: OECD?
Provide a short and direct response. 2.9. What is the ratio of the Mineral Rent(as % of GDP) in Coal in Fragile and conflict affected situations to that in Latin America(all income levels)?
Offer a terse response. 1.31. What is the ratio of the Mineral Rent(as % of GDP) of Natural Gas in Fragile and conflict affected situations to that in Latin America(all income levels)?
Provide a short and direct response. 1.47. What is the ratio of the Mineral Rent(as % of GDP) of Oil in Fragile and conflict affected situations to that in Latin America(all income levels)?
Your response must be concise. 5.66. What is the ratio of the Mineral Rent(as % of GDP) of Other Minerals in Fragile and conflict affected situations to that in Latin America(all income levels)?
Give a very brief answer. 0.45. What is the ratio of the Mineral Rent(as % of GDP) in Coal in Heavily indebted poor countries to that in High income?
Your response must be concise. 0.11. What is the ratio of the Mineral Rent(as % of GDP) in Natural Gas in Heavily indebted poor countries to that in High income?
Your response must be concise. 1.53. What is the ratio of the Mineral Rent(as % of GDP) in Oil in Heavily indebted poor countries to that in High income?
Provide a succinct answer. 2.82. What is the ratio of the Mineral Rent(as % of GDP) in Other Minerals in Heavily indebted poor countries to that in High income?
Offer a very short reply. 9.23. What is the ratio of the Mineral Rent(as % of GDP) of Coal in Heavily indebted poor countries to that in High income: nonOECD?
Ensure brevity in your answer.  0.04. What is the ratio of the Mineral Rent(as % of GDP) in Natural Gas in Heavily indebted poor countries to that in High income: nonOECD?
Give a very brief answer. 0.24. What is the ratio of the Mineral Rent(as % of GDP) of Oil in Heavily indebted poor countries to that in High income: nonOECD?
Your answer should be very brief. 0.39. What is the ratio of the Mineral Rent(as % of GDP) of Other Minerals in Heavily indebted poor countries to that in High income: nonOECD?
Offer a very short reply. 5.82. What is the ratio of the Mineral Rent(as % of GDP) of Coal in Heavily indebted poor countries to that in High income: OECD?
Keep it short and to the point. 0.14. What is the ratio of the Mineral Rent(as % of GDP) in Natural Gas in Heavily indebted poor countries to that in High income: OECD?
Ensure brevity in your answer.  3.79. What is the ratio of the Mineral Rent(as % of GDP) in Oil in Heavily indebted poor countries to that in High income: OECD?
Ensure brevity in your answer.  9.93. What is the ratio of the Mineral Rent(as % of GDP) in Other Minerals in Heavily indebted poor countries to that in High income: OECD?
Provide a short and direct response. 9.89. What is the ratio of the Mineral Rent(as % of GDP) in Coal in Heavily indebted poor countries to that in Latin America(all income levels)?
Provide a succinct answer. 0.23. What is the ratio of the Mineral Rent(as % of GDP) of Natural Gas in Heavily indebted poor countries to that in Latin America(all income levels)?
Provide a succinct answer. 1.17. What is the ratio of the Mineral Rent(as % of GDP) in Oil in Heavily indebted poor countries to that in Latin America(all income levels)?
Make the answer very short. 1.32. What is the ratio of the Mineral Rent(as % of GDP) in Other Minerals in Heavily indebted poor countries to that in Latin America(all income levels)?
Keep it short and to the point. 1.53. What is the ratio of the Mineral Rent(as % of GDP) in Coal in High income to that in High income: nonOECD?
Ensure brevity in your answer.  0.39. What is the ratio of the Mineral Rent(as % of GDP) in Natural Gas in High income to that in High income: nonOECD?
Offer a terse response. 0.16. What is the ratio of the Mineral Rent(as % of GDP) of Oil in High income to that in High income: nonOECD?
Offer a terse response. 0.14. What is the ratio of the Mineral Rent(as % of GDP) of Other Minerals in High income to that in High income: nonOECD?
Your response must be concise. 0.63. What is the ratio of the Mineral Rent(as % of GDP) in Coal in High income to that in High income: OECD?
Offer a very short reply. 1.22. What is the ratio of the Mineral Rent(as % of GDP) of Natural Gas in High income to that in High income: OECD?
Keep it short and to the point. 2.48. What is the ratio of the Mineral Rent(as % of GDP) of Oil in High income to that in High income: OECD?
Keep it short and to the point. 3.52. What is the ratio of the Mineral Rent(as % of GDP) in Other Minerals in High income to that in High income: OECD?
Ensure brevity in your answer.  1.07. What is the ratio of the Mineral Rent(as % of GDP) of Coal in High income to that in Latin America(all income levels)?
Provide a short and direct response. 2.07. What is the ratio of the Mineral Rent(as % of GDP) in Natural Gas in High income to that in Latin America(all income levels)?
Provide a succinct answer. 0.76. What is the ratio of the Mineral Rent(as % of GDP) in Oil in High income to that in Latin America(all income levels)?
Provide a succinct answer. 0.47. What is the ratio of the Mineral Rent(as % of GDP) of Other Minerals in High income to that in Latin America(all income levels)?
Keep it short and to the point. 0.17. What is the ratio of the Mineral Rent(as % of GDP) of Coal in High income: nonOECD to that in High income: OECD?
Your answer should be compact. 3.17. What is the ratio of the Mineral Rent(as % of GDP) in Natural Gas in High income: nonOECD to that in High income: OECD?
Keep it short and to the point. 15.46. What is the ratio of the Mineral Rent(as % of GDP) of Oil in High income: nonOECD to that in High income: OECD?
Keep it short and to the point. 25.66. What is the ratio of the Mineral Rent(as % of GDP) in Other Minerals in High income: nonOECD to that in High income: OECD?
Provide a succinct answer. 1.7. What is the ratio of the Mineral Rent(as % of GDP) in Coal in High income: nonOECD to that in Latin America(all income levels)?
Make the answer very short. 5.35. What is the ratio of the Mineral Rent(as % of GDP) in Natural Gas in High income: nonOECD to that in Latin America(all income levels)?
Your response must be concise. 4.77. What is the ratio of the Mineral Rent(as % of GDP) of Oil in High income: nonOECD to that in Latin America(all income levels)?
Give a very brief answer. 3.41. What is the ratio of the Mineral Rent(as % of GDP) in Other Minerals in High income: nonOECD to that in Latin America(all income levels)?
Offer a terse response. 0.26. What is the ratio of the Mineral Rent(as % of GDP) in Coal in High income: OECD to that in Latin America(all income levels)?
Your answer should be very brief. 1.69. What is the ratio of the Mineral Rent(as % of GDP) of Natural Gas in High income: OECD to that in Latin America(all income levels)?
Offer a terse response. 0.31. What is the ratio of the Mineral Rent(as % of GDP) in Oil in High income: OECD to that in Latin America(all income levels)?
Your response must be concise. 0.13. What is the ratio of the Mineral Rent(as % of GDP) in Other Minerals in High income: OECD to that in Latin America(all income levels)?
Ensure brevity in your answer.  0.15. What is the difference between the highest and the second highest Mineral Rent(as % of GDP) in Coal?
Offer a terse response. 0.21. What is the difference between the highest and the second highest Mineral Rent(as % of GDP) in Natural Gas?
Your answer should be compact. 1.72. What is the difference between the highest and the second highest Mineral Rent(as % of GDP) of Oil?
Give a very brief answer. 9.79. What is the difference between the highest and the second highest Mineral Rent(as % of GDP) in Other Minerals?
Your answer should be compact. 1.26. What is the difference between the highest and the lowest Mineral Rent(as % of GDP) in Coal?
Give a very brief answer. 0.32. What is the difference between the highest and the lowest Mineral Rent(as % of GDP) in Natural Gas?
Provide a succinct answer. 2.33. What is the difference between the highest and the lowest Mineral Rent(as % of GDP) in Oil?
Make the answer very short. 23.98. What is the difference between the highest and the lowest Mineral Rent(as % of GDP) in Other Minerals?
Give a very brief answer. 3.29. 